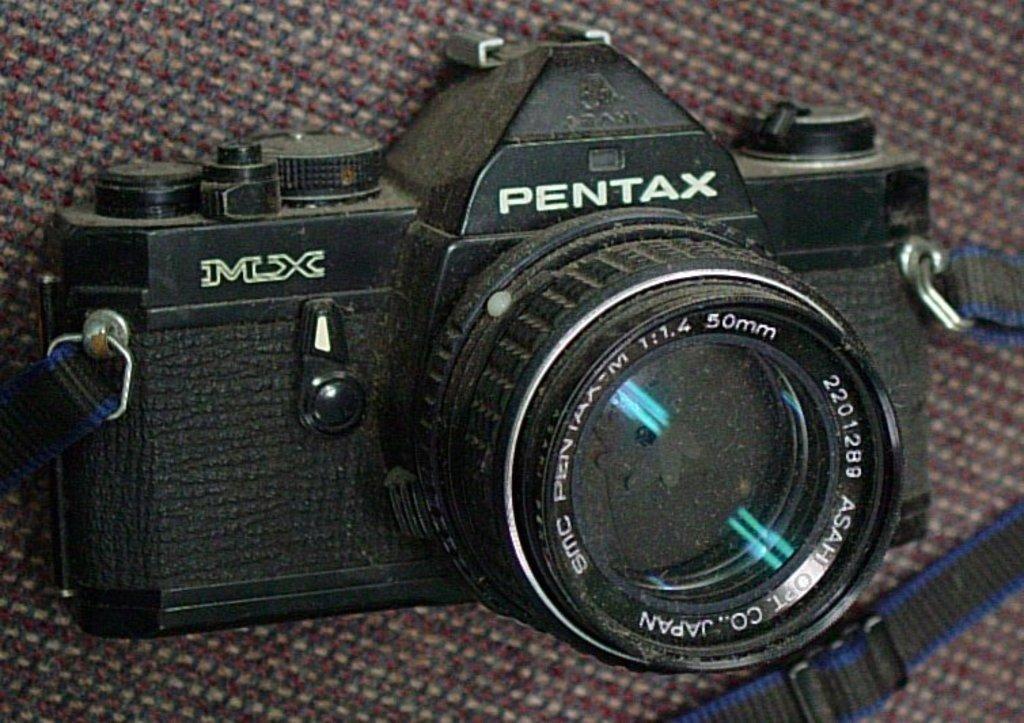Can you describe this image briefly? In this picture we can see some text and numbers on a camera. We can see a strap on this camera. 